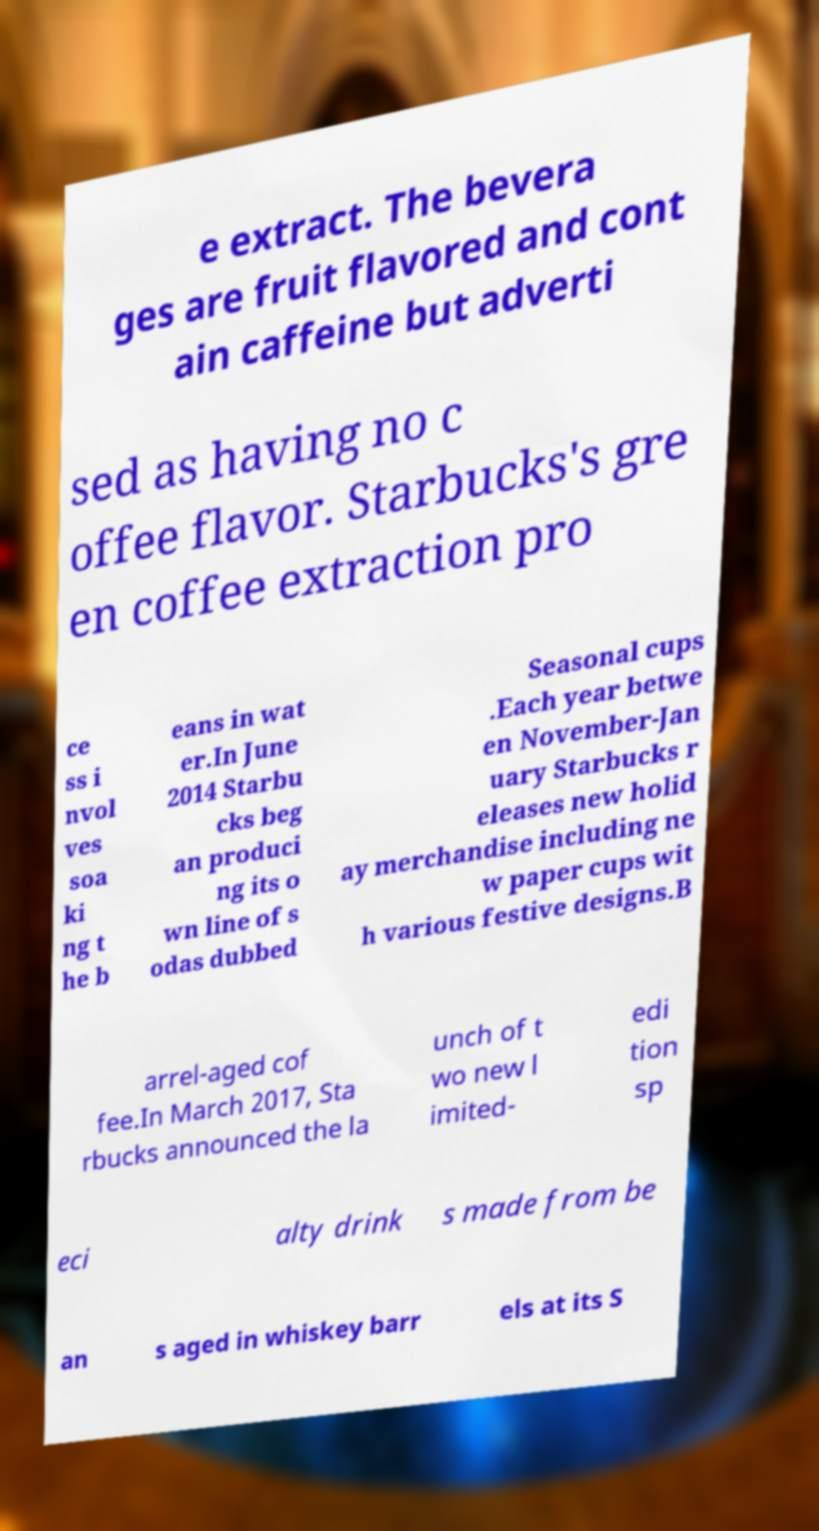Please read and relay the text visible in this image. What does it say? e extract. The bevera ges are fruit flavored and cont ain caffeine but adverti sed as having no c offee flavor. Starbucks's gre en coffee extraction pro ce ss i nvol ves soa ki ng t he b eans in wat er.In June 2014 Starbu cks beg an produci ng its o wn line of s odas dubbed Seasonal cups .Each year betwe en November-Jan uary Starbucks r eleases new holid ay merchandise including ne w paper cups wit h various festive designs.B arrel-aged cof fee.In March 2017, Sta rbucks announced the la unch of t wo new l imited- edi tion sp eci alty drink s made from be an s aged in whiskey barr els at its S 